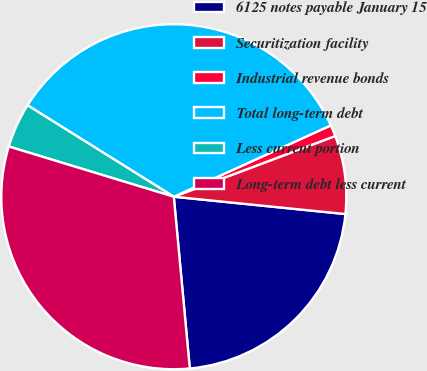<chart> <loc_0><loc_0><loc_500><loc_500><pie_chart><fcel>6125 notes payable January 15<fcel>Securitization facility<fcel>Industrial revenue bonds<fcel>Total long-term debt<fcel>Less current portion<fcel>Long-term debt less current<nl><fcel>21.92%<fcel>7.33%<fcel>1.06%<fcel>34.32%<fcel>4.19%<fcel>31.18%<nl></chart> 